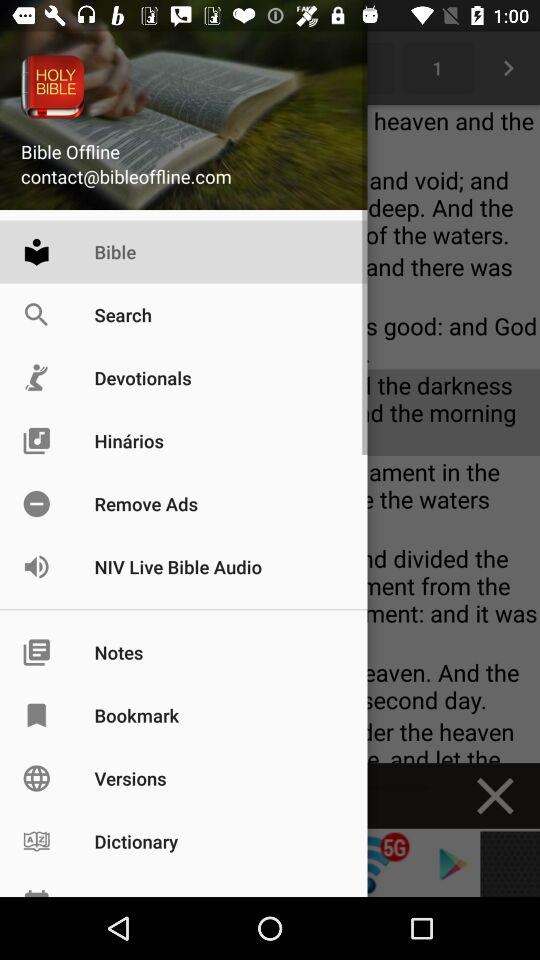What is the email address? The email address is contact@bibleoffline.com. 